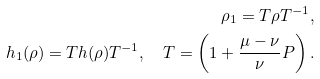<formula> <loc_0><loc_0><loc_500><loc_500>\rho _ { 1 } = T \rho T ^ { - 1 } , \\ h _ { 1 } ( \rho ) = T h ( \rho ) T ^ { - 1 } , \quad T = \left ( 1 + \frac { \mu - \nu } { \nu } P \right ) .</formula> 